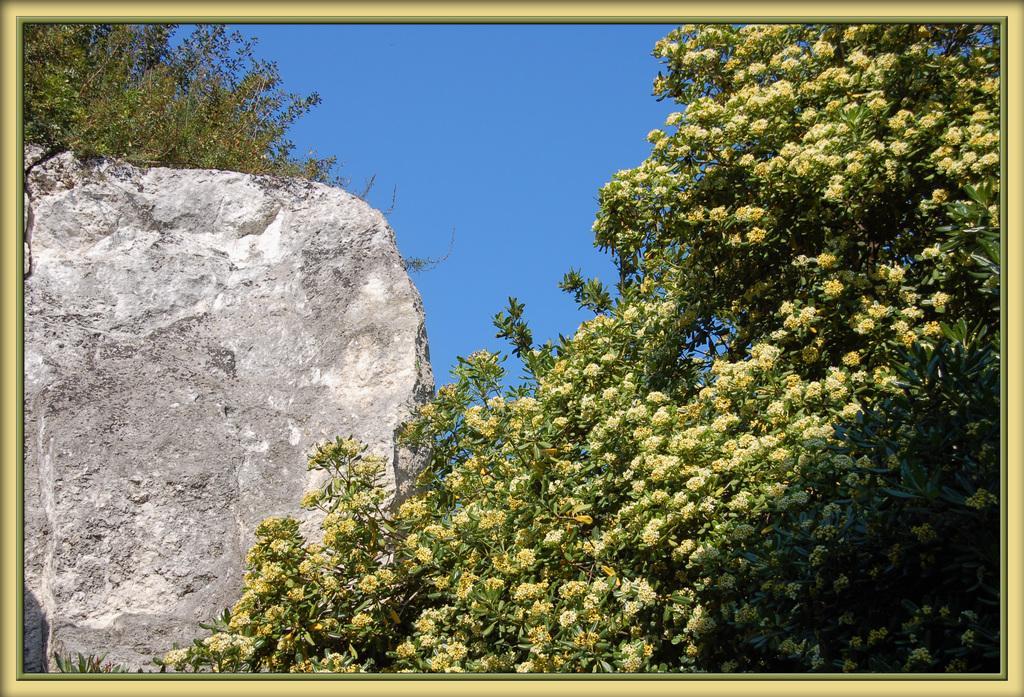Could you give a brief overview of what you see in this image? In this picture we can see a few flowers on the right side. There is a wall visible on the left side. We can see a few plants in the top left. Sky is blue in color. We can see a green border and a creamy border on this image. 